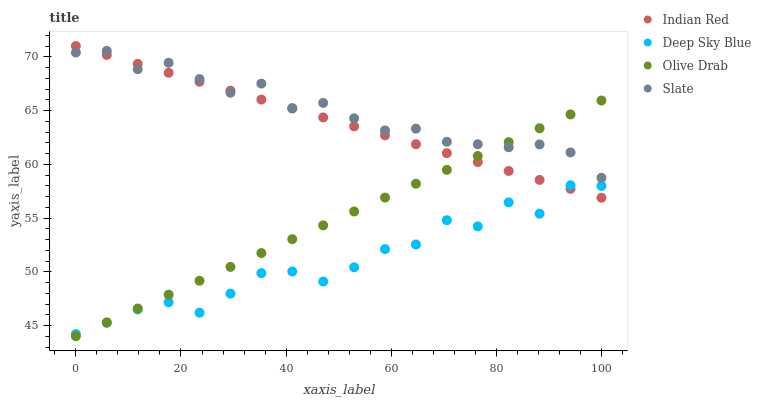Does Deep Sky Blue have the minimum area under the curve?
Answer yes or no. Yes. Does Slate have the maximum area under the curve?
Answer yes or no. Yes. Does Slate have the minimum area under the curve?
Answer yes or no. No. Does Deep Sky Blue have the maximum area under the curve?
Answer yes or no. No. Is Olive Drab the smoothest?
Answer yes or no. Yes. Is Deep Sky Blue the roughest?
Answer yes or no. Yes. Is Slate the smoothest?
Answer yes or no. No. Is Slate the roughest?
Answer yes or no. No. Does Olive Drab have the lowest value?
Answer yes or no. Yes. Does Deep Sky Blue have the lowest value?
Answer yes or no. No. Does Indian Red have the highest value?
Answer yes or no. Yes. Does Slate have the highest value?
Answer yes or no. No. Is Deep Sky Blue less than Slate?
Answer yes or no. Yes. Is Slate greater than Deep Sky Blue?
Answer yes or no. Yes. Does Slate intersect Olive Drab?
Answer yes or no. Yes. Is Slate less than Olive Drab?
Answer yes or no. No. Is Slate greater than Olive Drab?
Answer yes or no. No. Does Deep Sky Blue intersect Slate?
Answer yes or no. No. 